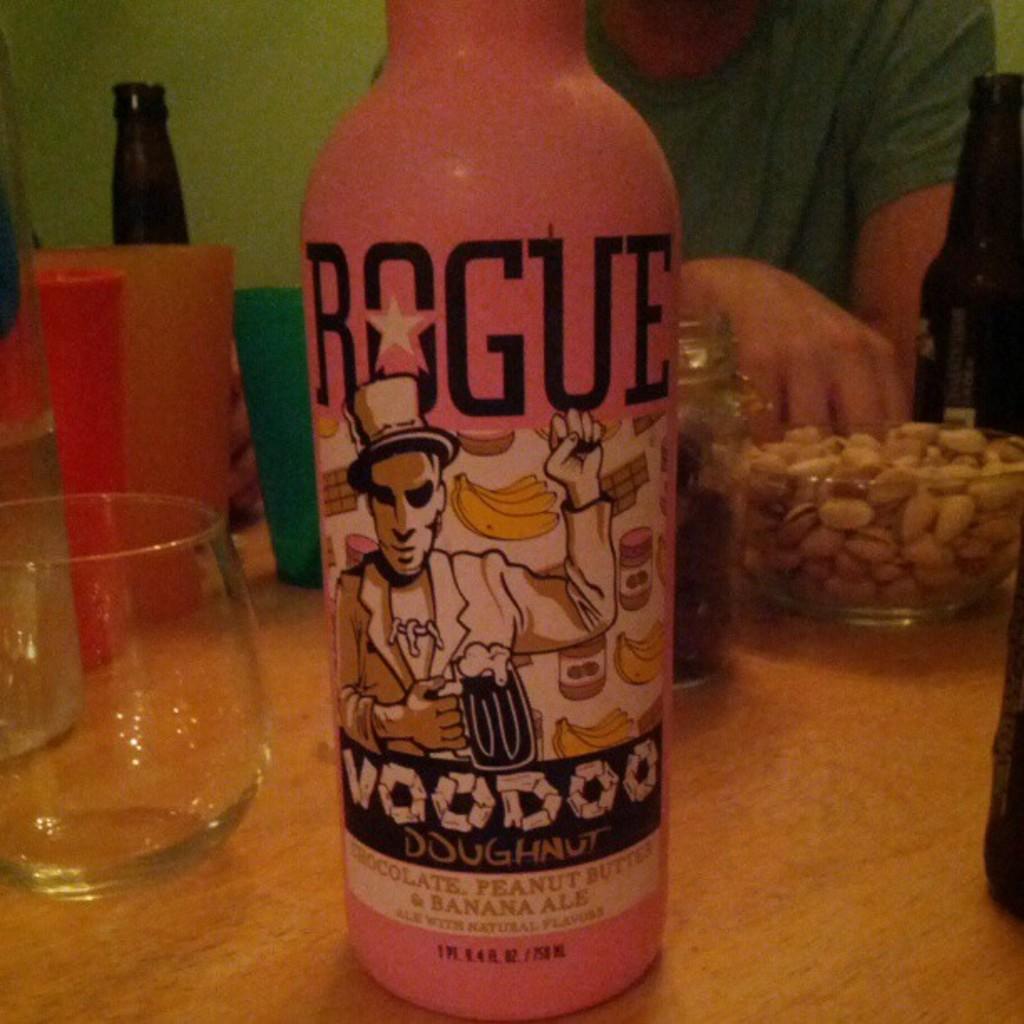What company made this ale?
Your response must be concise. Rogue. 